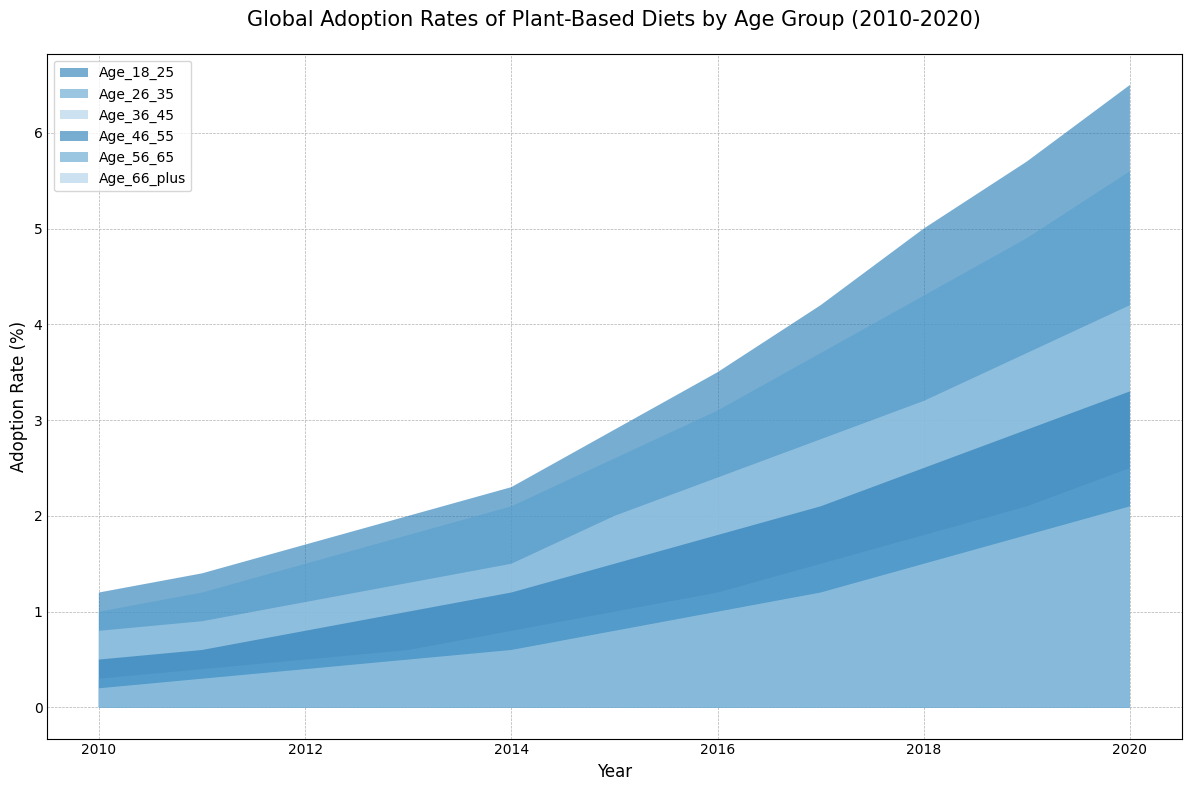Which age group had the highest adoption rate of plant-based diets in 2020? The age group with the highest adoption rate can be identified by finding the highest point on the chart for 2020. The figure shows that the group "Age_18_25" had the highest adoption rate.
Answer: Age_18_25 Did the adoption rate for the "Age_46_55" group increase more from 2010 to 2020 compared to the "Age_56_65" group? Calculate the difference in adoption rates for both groups between 2010 and 2020. For "Age_46_55," the increase is 3.3 - 0.5 = 2.8. For "Age_56_65," the increase is 2.5 - 0.3 = 2.2. Since 2.8 is greater than 2.2, the "Age_46_55" group had a larger increase.
Answer: Yes Which age group had the slowest growth in adoption rate over the decade? Identify the age group with the smallest increase in adoption rate from 2010 to 2020. The "Age_66_plus" group increased from 0.2 to 2.1, resulting in an increase of 1.9, which is the smallest among all groups.
Answer: Age_66_plus What was the difference in adoption rate for the "Age_18_25" group between 2014 and 2018? Find the adoption rates for "Age_18_25" in 2014 and 2018, which are 2.3 and 5.0 respectively. Calculate the difference: 5.0 - 2.3 = 2.7.
Answer: 2.7 How did the relative size of the age groups' adoption rates change from 2015 to 2020? Compare the heights of the areas for each age group from 2015 to 2020. While all groups increased, the change in the dominance of the age groups' sizes can be inferred. "Age_18_25" maintains the highest adoption rate, and the gap between it and other groups grows.
Answer: The "Age_18_25" group maintained and widened its lead Which age group showed the largest increase in adoption rate in 2016 compared to the previous year? Calculate the increase in adoption rate from 2015 to 2016 for each age group. The "Age_18_25" shows the largest increase, growing from 2.9 to 3.5, an increase of 0.6.
Answer: Age_18_25 In which year did the "Age_26_35" group first reach an adoption rate of over 4%? By observing the area chart, the adoption rate for "Age_26_35" crossed the 4% mark in 2018.
Answer: 2018 Which two age groups had the closest adoption rates in 2020? Compare the adoption rates of each age group in 2020. The groups "Age_46_55" and "Age_36_45" had adoption rates of 3.3 and 4.2, respectively, with a difference of 0.9. Any other pair has a larger difference.
Answer: Age_46_55 and Age_36_45 How did the adoption rate for the "Age_36_45" group change from 2012 to 2017? Identify the adoption rates for "Age_36_45" in 2012 (1.1) and 2017 (2.8). Calculate the change: 2.8 - 1.1 = 1.7.
Answer: Increased by 1.7 Which age group maintained the second highest adoption rate consistently from 2018 to 2020? Observing the area chart, the "Age_26_35" group consistently maintained the second highest adoption rate after "Age_18_25" from 2018 to 2020.
Answer: Age_26_35 